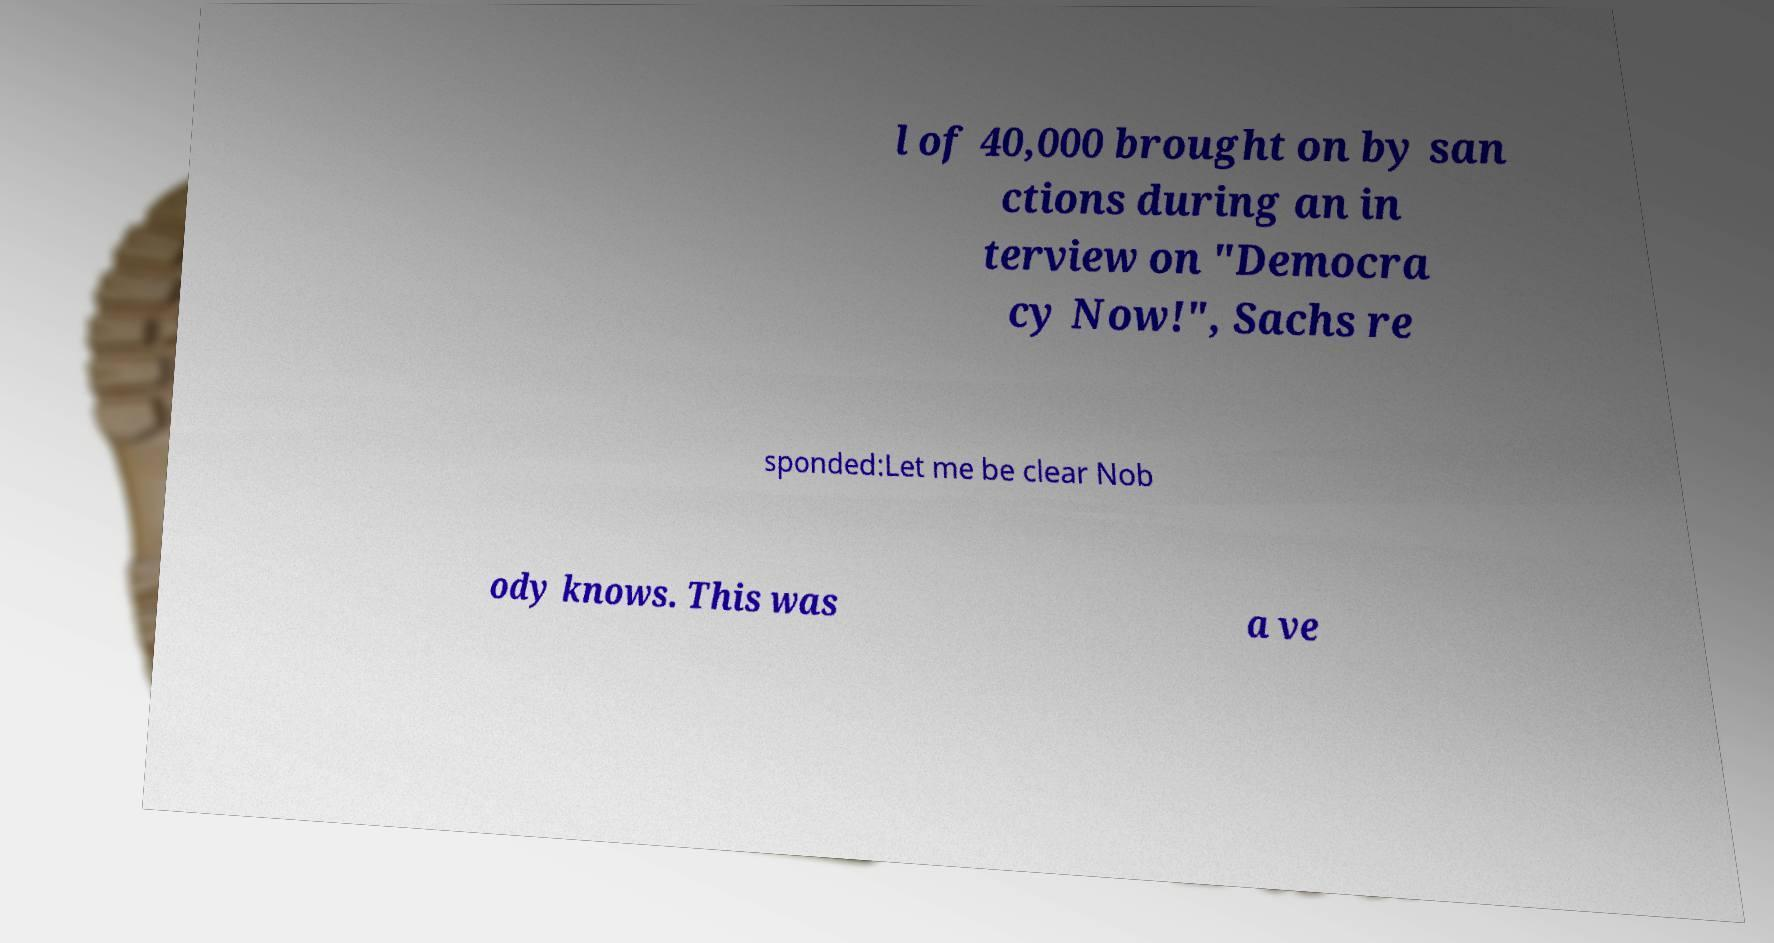I need the written content from this picture converted into text. Can you do that? l of 40,000 brought on by san ctions during an in terview on "Democra cy Now!", Sachs re sponded:Let me be clear Nob ody knows. This was a ve 